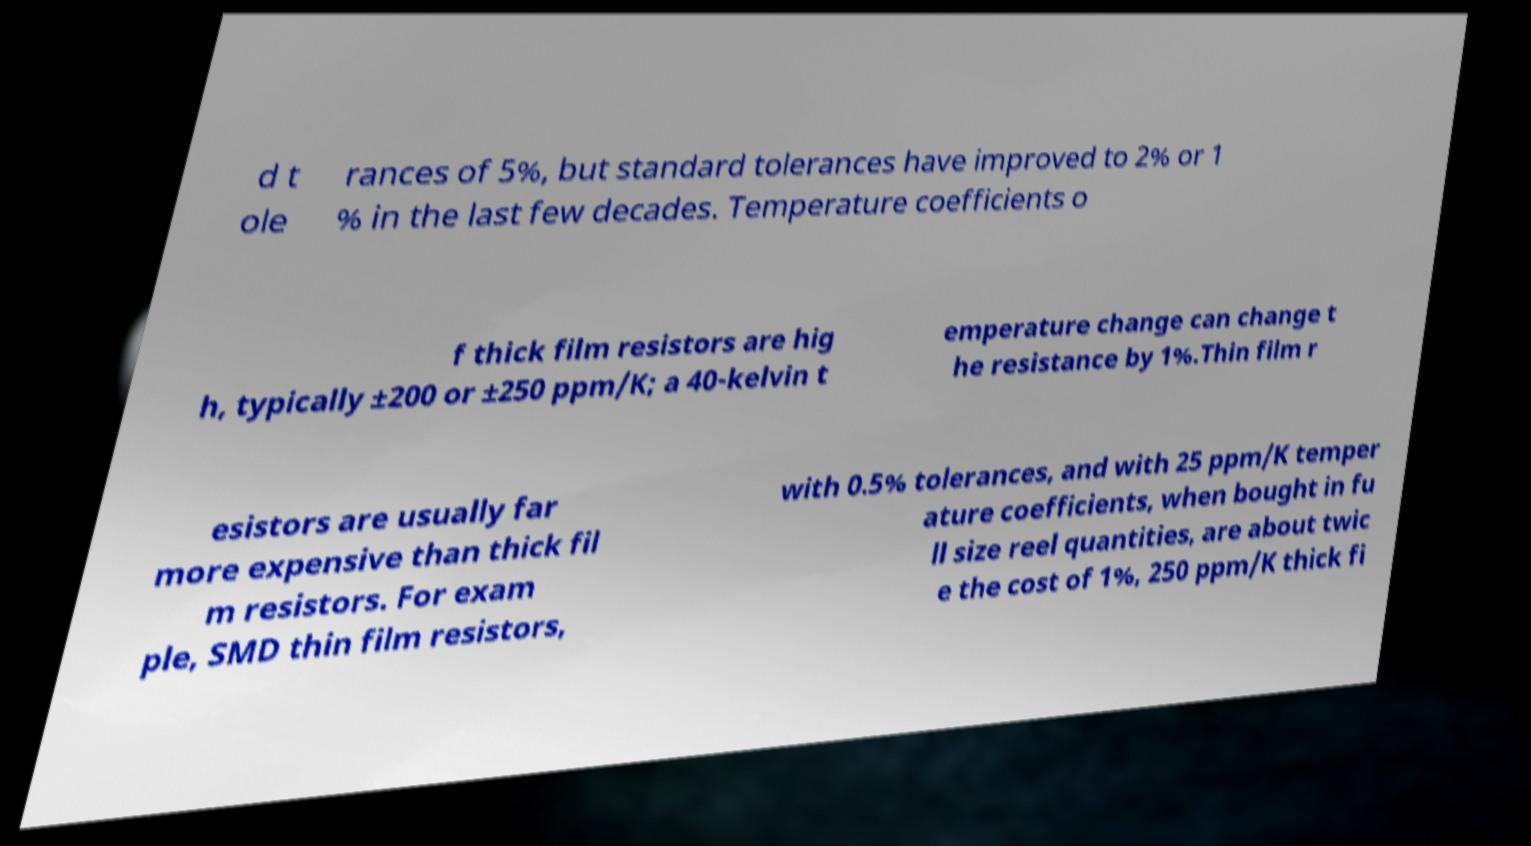Can you accurately transcribe the text from the provided image for me? d t ole rances of 5%, but standard tolerances have improved to 2% or 1 % in the last few decades. Temperature coefficients o f thick film resistors are hig h, typically ±200 or ±250 ppm/K; a 40-kelvin t emperature change can change t he resistance by 1%.Thin film r esistors are usually far more expensive than thick fil m resistors. For exam ple, SMD thin film resistors, with 0.5% tolerances, and with 25 ppm/K temper ature coefficients, when bought in fu ll size reel quantities, are about twic e the cost of 1%, 250 ppm/K thick fi 